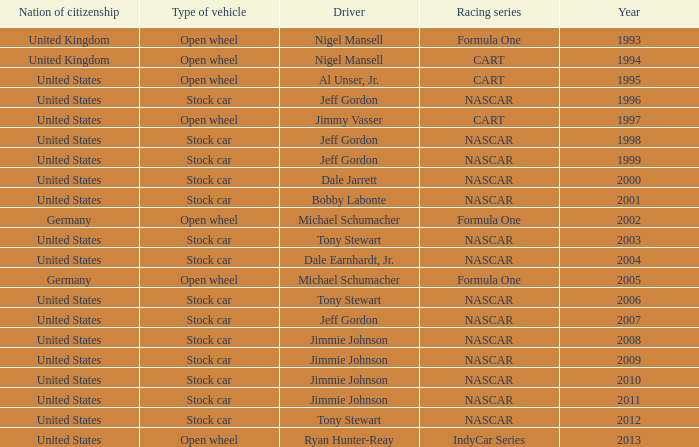What driver has a stock car vehicle with a year of 1999? Jeff Gordon. 